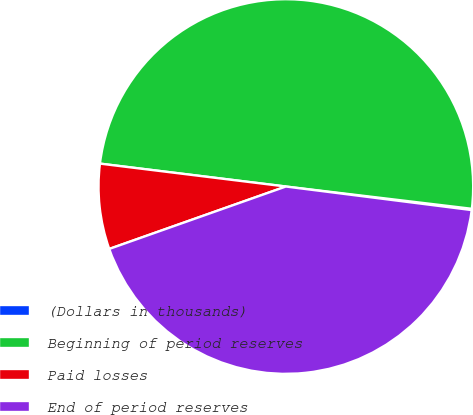Convert chart. <chart><loc_0><loc_0><loc_500><loc_500><pie_chart><fcel>(Dollars in thousands)<fcel>Beginning of period reserves<fcel>Paid losses<fcel>End of period reserves<nl><fcel>0.11%<fcel>49.95%<fcel>7.36%<fcel>42.59%<nl></chart> 